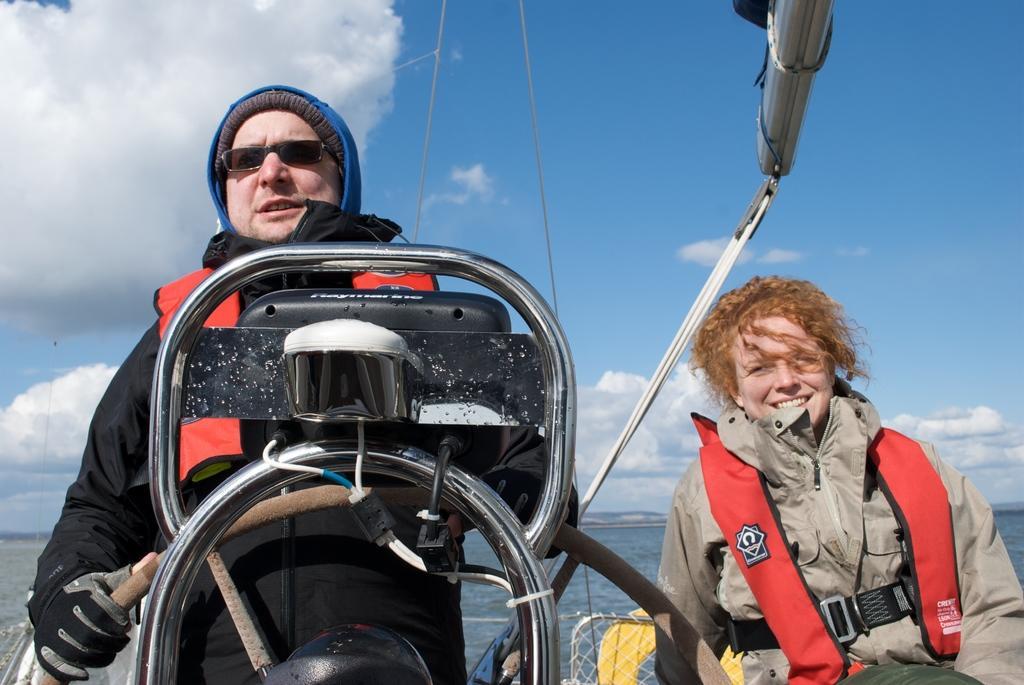Please provide a concise description of this image. In the front of the image there are people, rods, mesh, tub and objects. People wore jackets. In the background of the image there is water and cloudy sky. A person wore goggles, gloves and he is holding an object. 